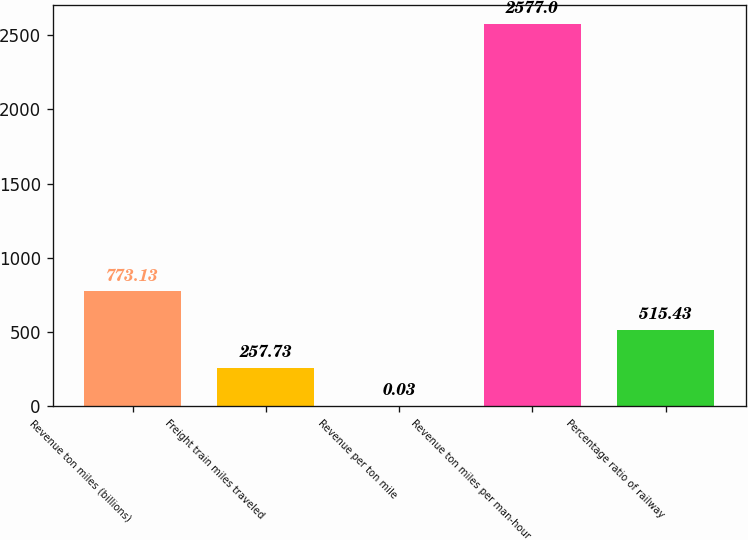<chart> <loc_0><loc_0><loc_500><loc_500><bar_chart><fcel>Revenue ton miles (billions)<fcel>Freight train miles traveled<fcel>Revenue per ton mile<fcel>Revenue ton miles per man-hour<fcel>Percentage ratio of railway<nl><fcel>773.13<fcel>257.73<fcel>0.03<fcel>2577<fcel>515.43<nl></chart> 